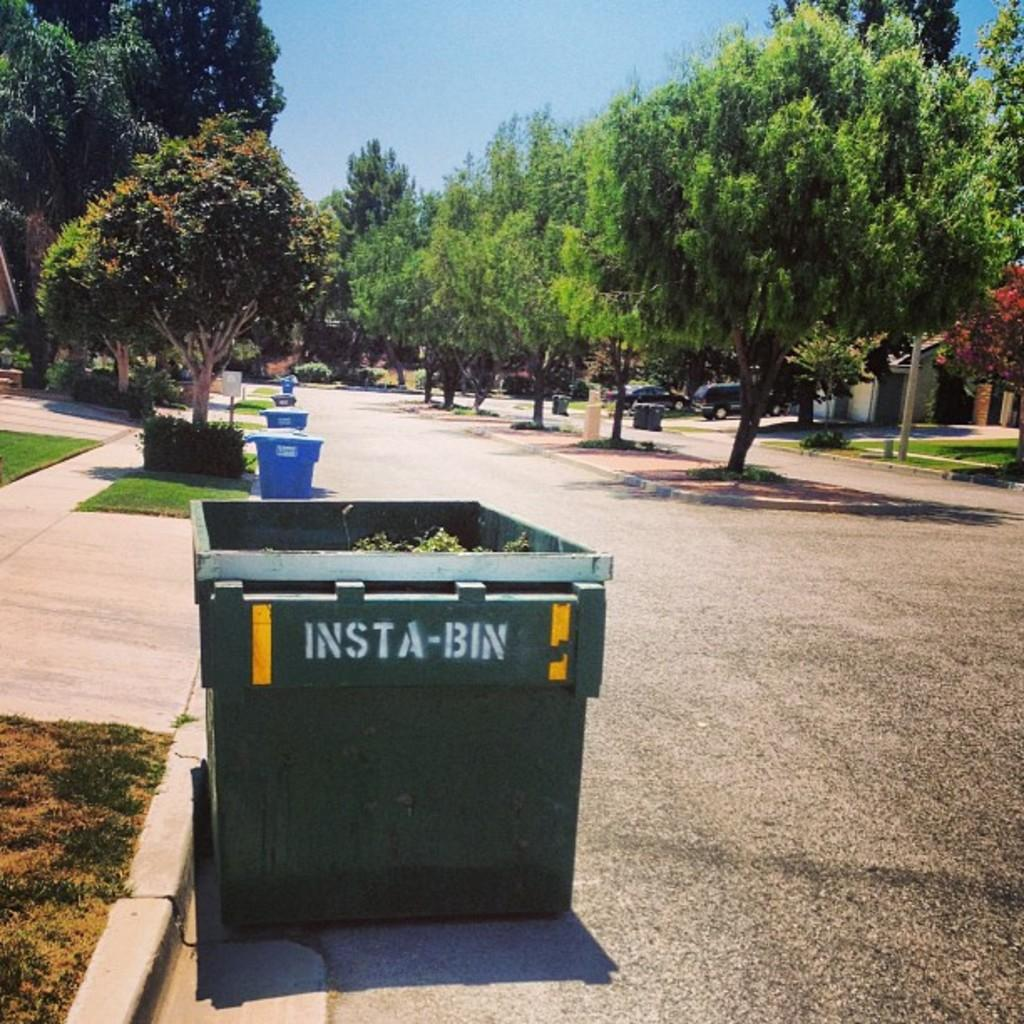<image>
Relay a brief, clear account of the picture shown. "INSTA-BIN" is on the side of a trash bin. 